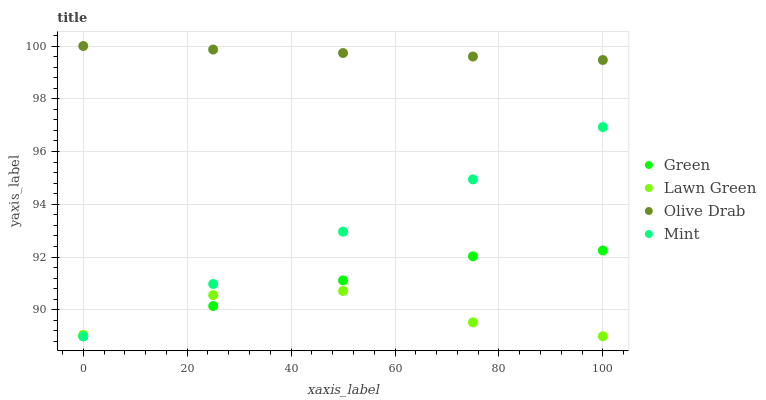Does Lawn Green have the minimum area under the curve?
Answer yes or no. Yes. Does Olive Drab have the maximum area under the curve?
Answer yes or no. Yes. Does Green have the minimum area under the curve?
Answer yes or no. No. Does Green have the maximum area under the curve?
Answer yes or no. No. Is Olive Drab the smoothest?
Answer yes or no. Yes. Is Lawn Green the roughest?
Answer yes or no. Yes. Is Green the smoothest?
Answer yes or no. No. Is Green the roughest?
Answer yes or no. No. Does Lawn Green have the lowest value?
Answer yes or no. Yes. Does Olive Drab have the lowest value?
Answer yes or no. No. Does Olive Drab have the highest value?
Answer yes or no. Yes. Does Green have the highest value?
Answer yes or no. No. Is Lawn Green less than Olive Drab?
Answer yes or no. Yes. Is Olive Drab greater than Mint?
Answer yes or no. Yes. Does Lawn Green intersect Green?
Answer yes or no. Yes. Is Lawn Green less than Green?
Answer yes or no. No. Is Lawn Green greater than Green?
Answer yes or no. No. Does Lawn Green intersect Olive Drab?
Answer yes or no. No. 